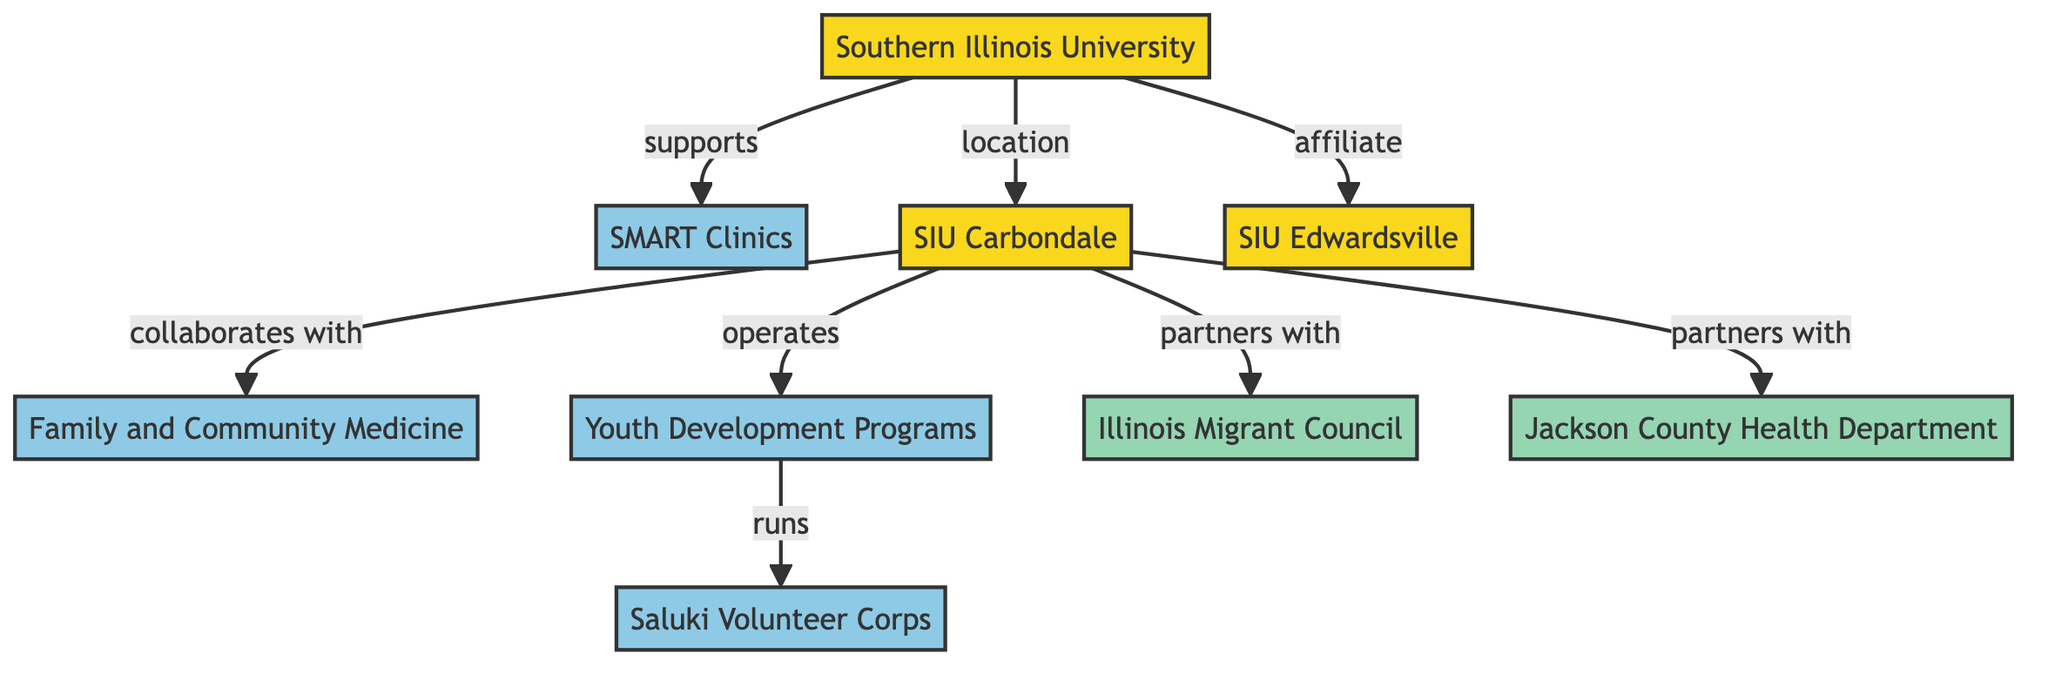What is the primary university represented in the diagram? The diagram shows Southern Illinois University at the top as the main university node.
Answer: Southern Illinois University How many programs are directly supported by Southern Illinois University? There are four programs listed that are supported directly: SMART Clinics, Family and Community Medicine, Youth Development Programs, and Saluki Volunteer Corps.
Answer: 4 Which program is linked to Family and Community Medicine? The diagram indicates that Family and Community Medicine collaborates with the university located at SIU Carbondale.
Answer: SIU Carbondale What type of relationship exists between SIU Carbondale and Jackson County Health Department? The relationship is established as a partnership, as indicated by the direct link in the diagram.
Answer: partners How many universities are affiliated with Southern Illinois University in the diagram? The diagram shows two universities: SIU Carbondale and SIU Edwardsville, as affiliates.
Answer: 2 What program runs Youth Development Programs? The diagram indicates that the Saluki Volunteer Corps runs the Youth Development Programs.
Answer: Saluki Volunteer Corps Which partner is associated with SIU Carbondale? SIU Carbondale has partnerships with Illinois Migrant Council and Jackson County Health Department, as demonstrated in the diagram.
Answer: Illinois Migrant Council, Jackson County Health Department What is the connection between SMART Clinics and Southern Illinois University? SMART Clinics are directly supported by Southern Illinois University, as shown by the linking arrow in the diagram.
Answer: supports How many total partnerships are illustrated in the diagram? The diagram illustrates three partnerships involving SIU Carbondale with two partners: Illinois Migrant Council and Jackson County Health Department.
Answer: 3 